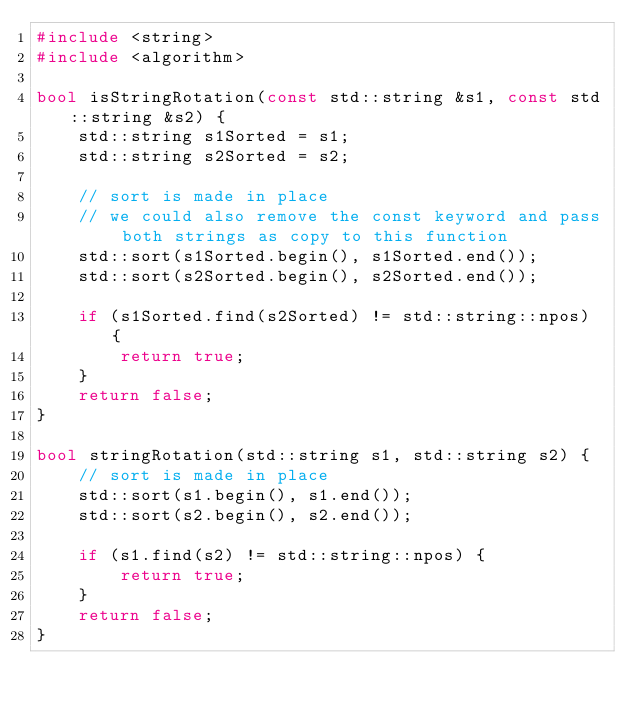Convert code to text. <code><loc_0><loc_0><loc_500><loc_500><_C++_>#include <string>
#include <algorithm>

bool isStringRotation(const std::string &s1, const std::string &s2) {
    std::string s1Sorted = s1;
    std::string s2Sorted = s2;

    // sort is made in place
    // we could also remove the const keyword and pass both strings as copy to this function
    std::sort(s1Sorted.begin(), s1Sorted.end());
    std::sort(s2Sorted.begin(), s2Sorted.end());

    if (s1Sorted.find(s2Sorted) != std::string::npos) {
        return true;
    }
    return false;
}

bool stringRotation(std::string s1, std::string s2) {
    // sort is made in place
    std::sort(s1.begin(), s1.end());
    std::sort(s2.begin(), s2.end());

    if (s1.find(s2) != std::string::npos) {
        return true;
    }
    return false;
}</code> 